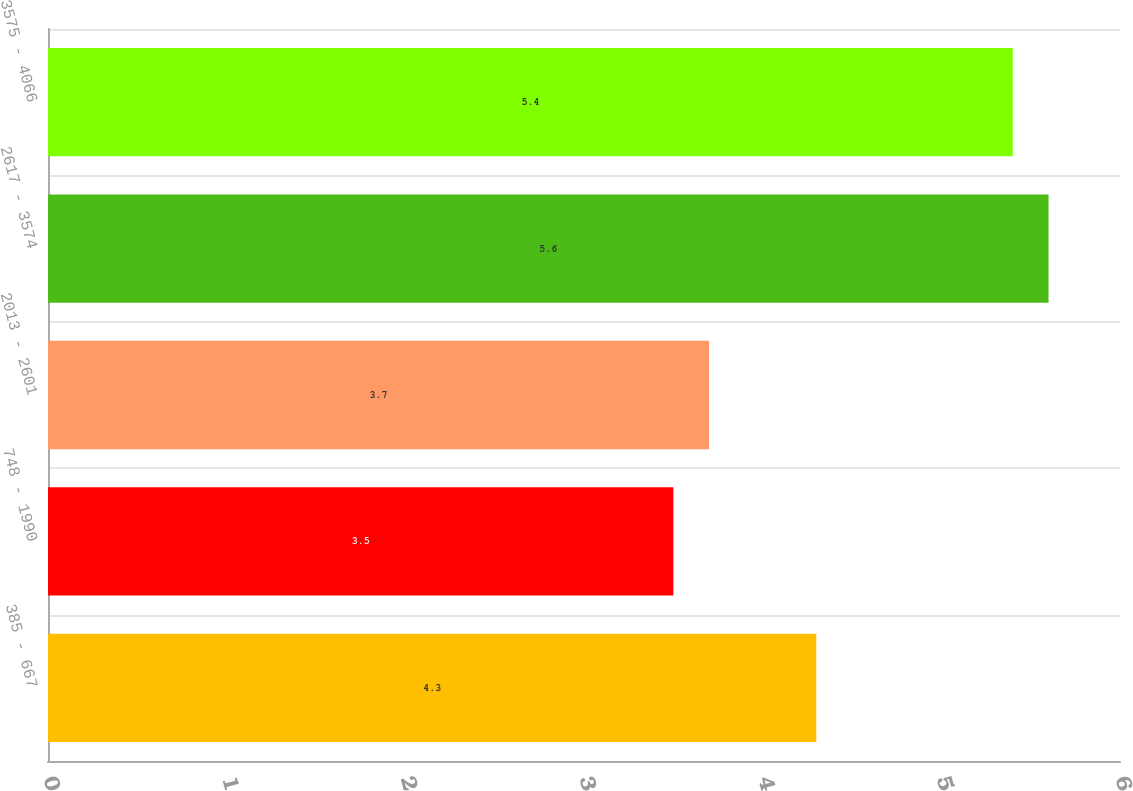<chart> <loc_0><loc_0><loc_500><loc_500><bar_chart><fcel>385 - 667<fcel>748 - 1990<fcel>2013 - 2601<fcel>2617 - 3574<fcel>3575 - 4066<nl><fcel>4.3<fcel>3.5<fcel>3.7<fcel>5.6<fcel>5.4<nl></chart> 